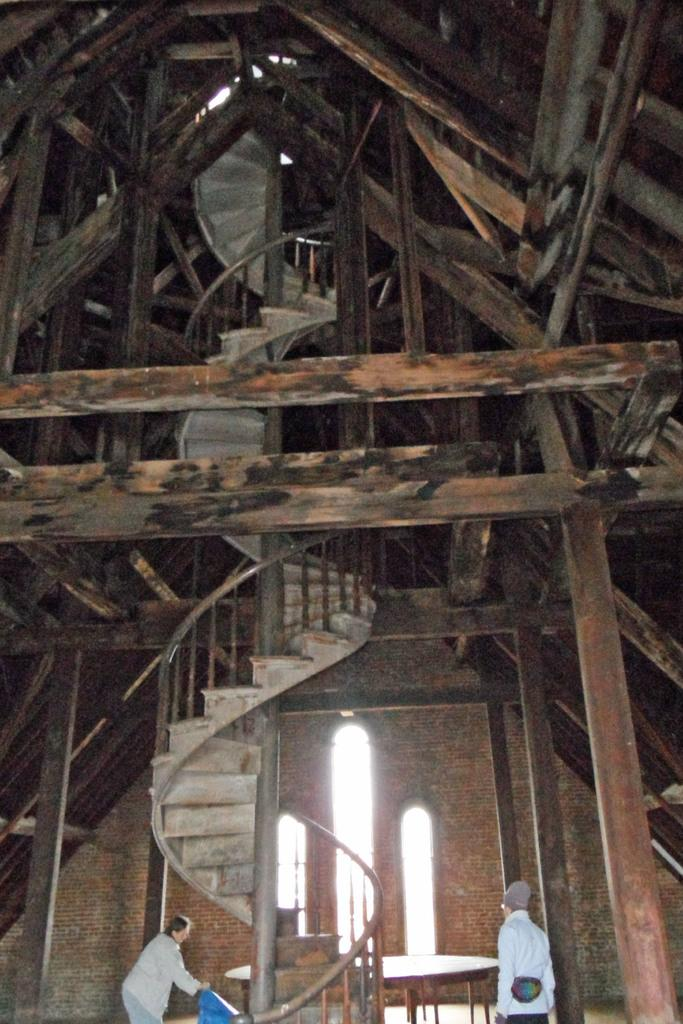What is the main subject of the image? The main subject of the image is a view of a building. What architectural feature can be seen in the image? There are stairs visible in the image. How many persons are present in the image? There are 2 persons in the image. What type of juice can be seen being served by the trees in the image? There are no trees or juice present in the image. Who is the partner of the person standing next to the stairs in the image? There is no reference to a partner or another person standing next to the stairs in the image. 